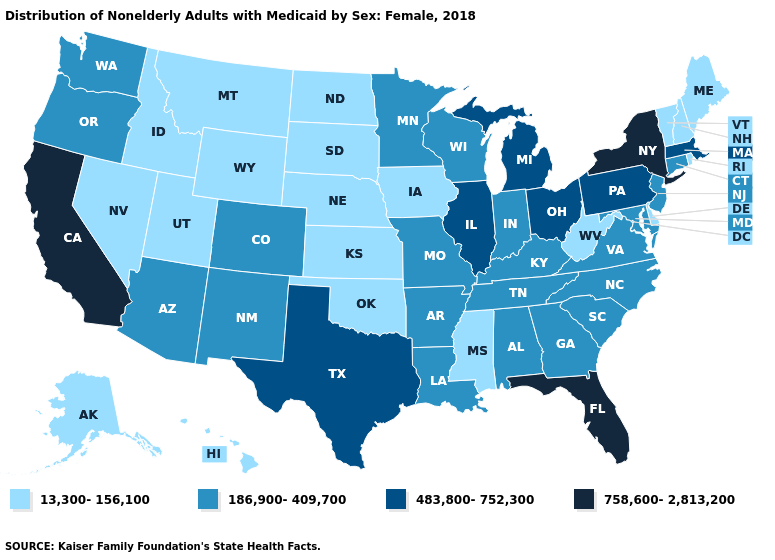What is the value of Connecticut?
Quick response, please. 186,900-409,700. Does Utah have the lowest value in the West?
Give a very brief answer. Yes. Name the states that have a value in the range 13,300-156,100?
Short answer required. Alaska, Delaware, Hawaii, Idaho, Iowa, Kansas, Maine, Mississippi, Montana, Nebraska, Nevada, New Hampshire, North Dakota, Oklahoma, Rhode Island, South Dakota, Utah, Vermont, West Virginia, Wyoming. Among the states that border Minnesota , does North Dakota have the lowest value?
Be succinct. Yes. Name the states that have a value in the range 483,800-752,300?
Concise answer only. Illinois, Massachusetts, Michigan, Ohio, Pennsylvania, Texas. Which states hav the highest value in the South?
Concise answer only. Florida. Does Pennsylvania have the highest value in the USA?
Answer briefly. No. Does Delaware have the lowest value in the South?
Give a very brief answer. Yes. What is the value of New Hampshire?
Short answer required. 13,300-156,100. Name the states that have a value in the range 186,900-409,700?
Answer briefly. Alabama, Arizona, Arkansas, Colorado, Connecticut, Georgia, Indiana, Kentucky, Louisiana, Maryland, Minnesota, Missouri, New Jersey, New Mexico, North Carolina, Oregon, South Carolina, Tennessee, Virginia, Washington, Wisconsin. Among the states that border Washington , which have the highest value?
Give a very brief answer. Oregon. Name the states that have a value in the range 758,600-2,813,200?
Be succinct. California, Florida, New York. Which states have the lowest value in the USA?
Give a very brief answer. Alaska, Delaware, Hawaii, Idaho, Iowa, Kansas, Maine, Mississippi, Montana, Nebraska, Nevada, New Hampshire, North Dakota, Oklahoma, Rhode Island, South Dakota, Utah, Vermont, West Virginia, Wyoming. Does Tennessee have the same value as Indiana?
Short answer required. Yes. Among the states that border Pennsylvania , does West Virginia have the highest value?
Answer briefly. No. 